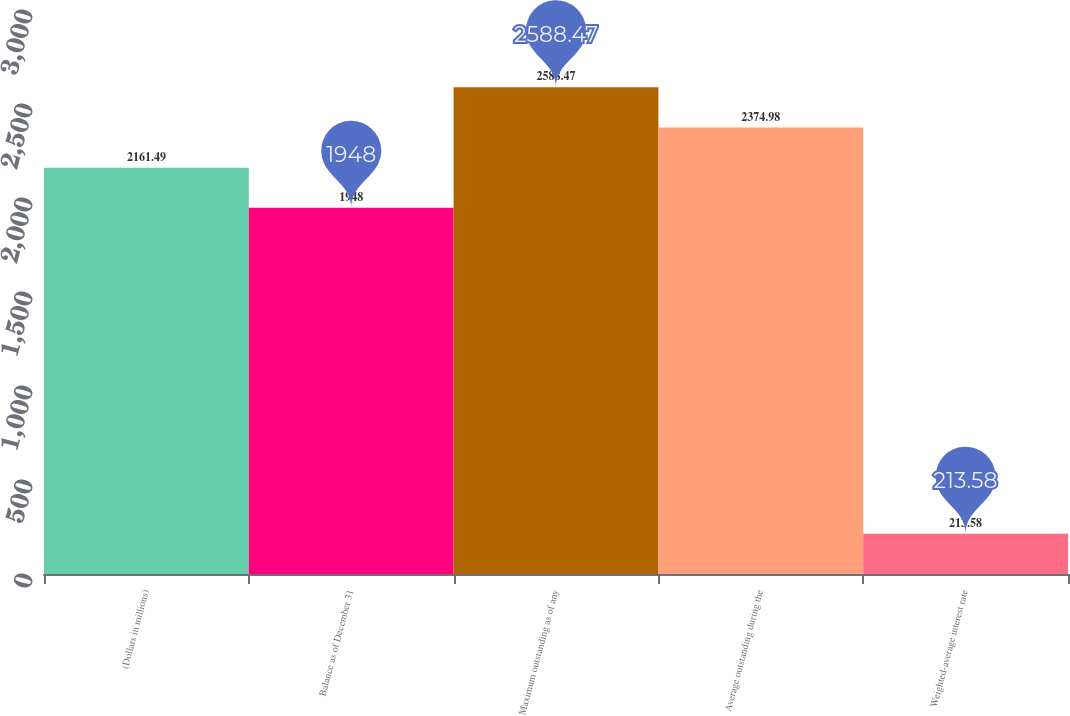Convert chart. <chart><loc_0><loc_0><loc_500><loc_500><bar_chart><fcel>(Dollars in millions)<fcel>Balance as of December 31<fcel>Maximum outstanding as of any<fcel>Average outstanding during the<fcel>Weighted-average interest rate<nl><fcel>2161.49<fcel>1948<fcel>2588.47<fcel>2374.98<fcel>213.58<nl></chart> 